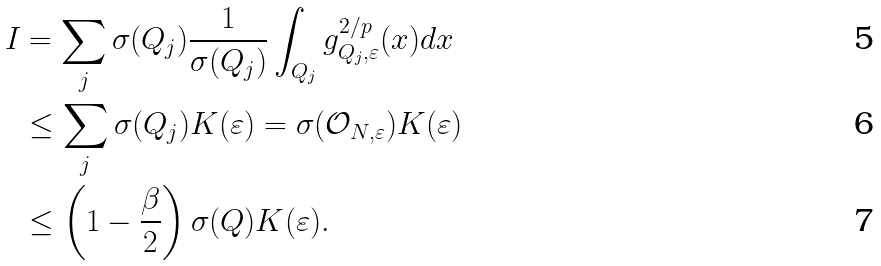<formula> <loc_0><loc_0><loc_500><loc_500>I & = \sum _ { j } \sigma ( Q _ { j } ) \frac { 1 } { \sigma ( Q _ { j } ) } \int _ { Q _ { j } } g _ { Q _ { j } , \varepsilon } ^ { 2 / p } ( x ) d x \\ & \leq \sum _ { j } \sigma ( Q _ { j } ) K ( \varepsilon ) = \sigma ( \mathcal { O } _ { N , \varepsilon } ) K ( \varepsilon ) \\ & \leq \left ( 1 - \frac { \beta } { 2 } \right ) \sigma ( Q ) K ( \varepsilon ) .</formula> 